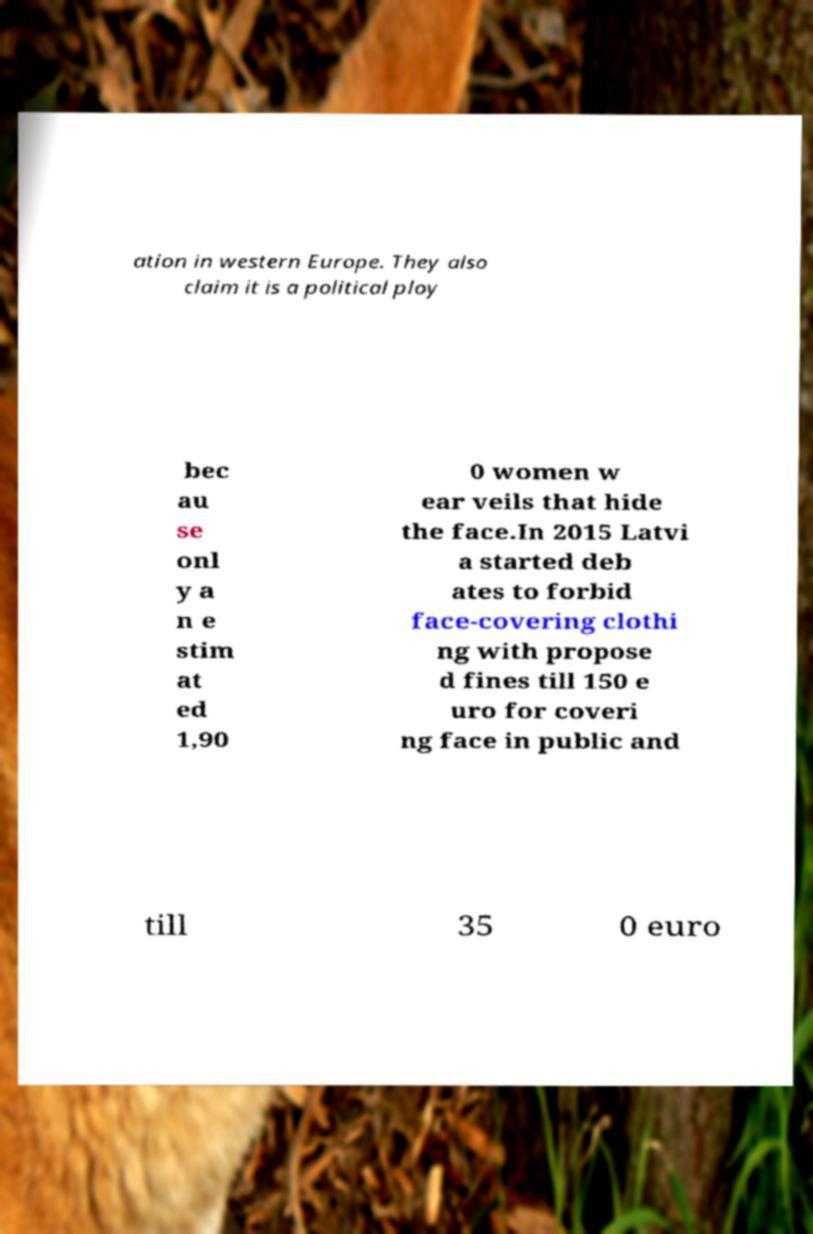Please read and relay the text visible in this image. What does it say? ation in western Europe. They also claim it is a political ploy bec au se onl y a n e stim at ed 1,90 0 women w ear veils that hide the face.In 2015 Latvi a started deb ates to forbid face-covering clothi ng with propose d fines till 150 e uro for coveri ng face in public and till 35 0 euro 